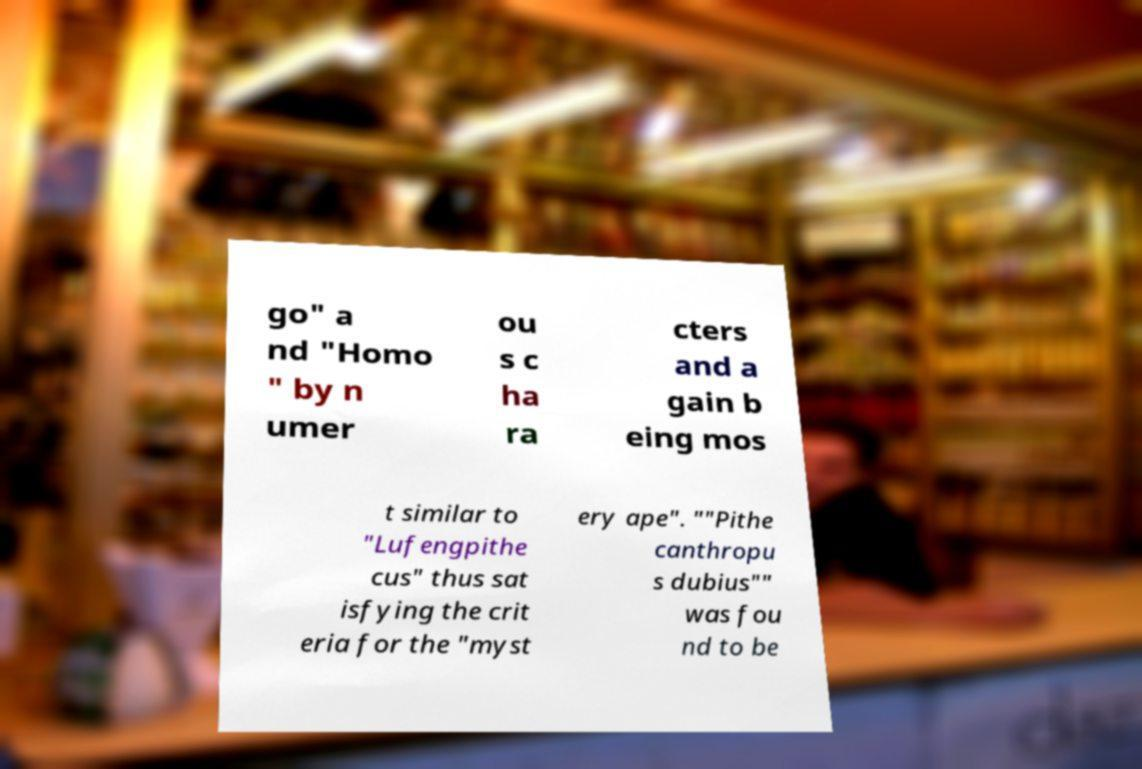Could you assist in decoding the text presented in this image and type it out clearly? go" a nd "Homo " by n umer ou s c ha ra cters and a gain b eing mos t similar to "Lufengpithe cus" thus sat isfying the crit eria for the "myst ery ape". ""Pithe canthropu s dubius"" was fou nd to be 